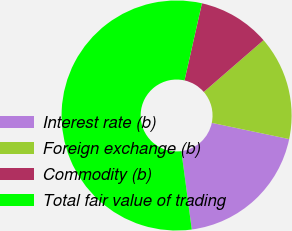<chart> <loc_0><loc_0><loc_500><loc_500><pie_chart><fcel>Interest rate (b)<fcel>Foreign exchange (b)<fcel>Commodity (b)<fcel>Total fair value of trading<nl><fcel>19.61%<fcel>14.65%<fcel>10.1%<fcel>55.64%<nl></chart> 